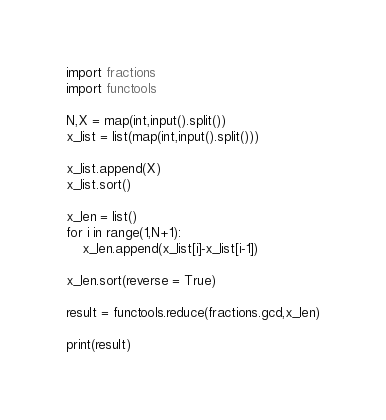<code> <loc_0><loc_0><loc_500><loc_500><_Python_>import fractions
import functools

N,X = map(int,input().split())
x_list = list(map(int,input().split()))

x_list.append(X)
x_list.sort()

x_len = list()
for i in range(1,N+1):
    x_len.append(x_list[i]-x_list[i-1])

x_len.sort(reverse = True)

result = functools.reduce(fractions.gcd,x_len)

print(result)</code> 